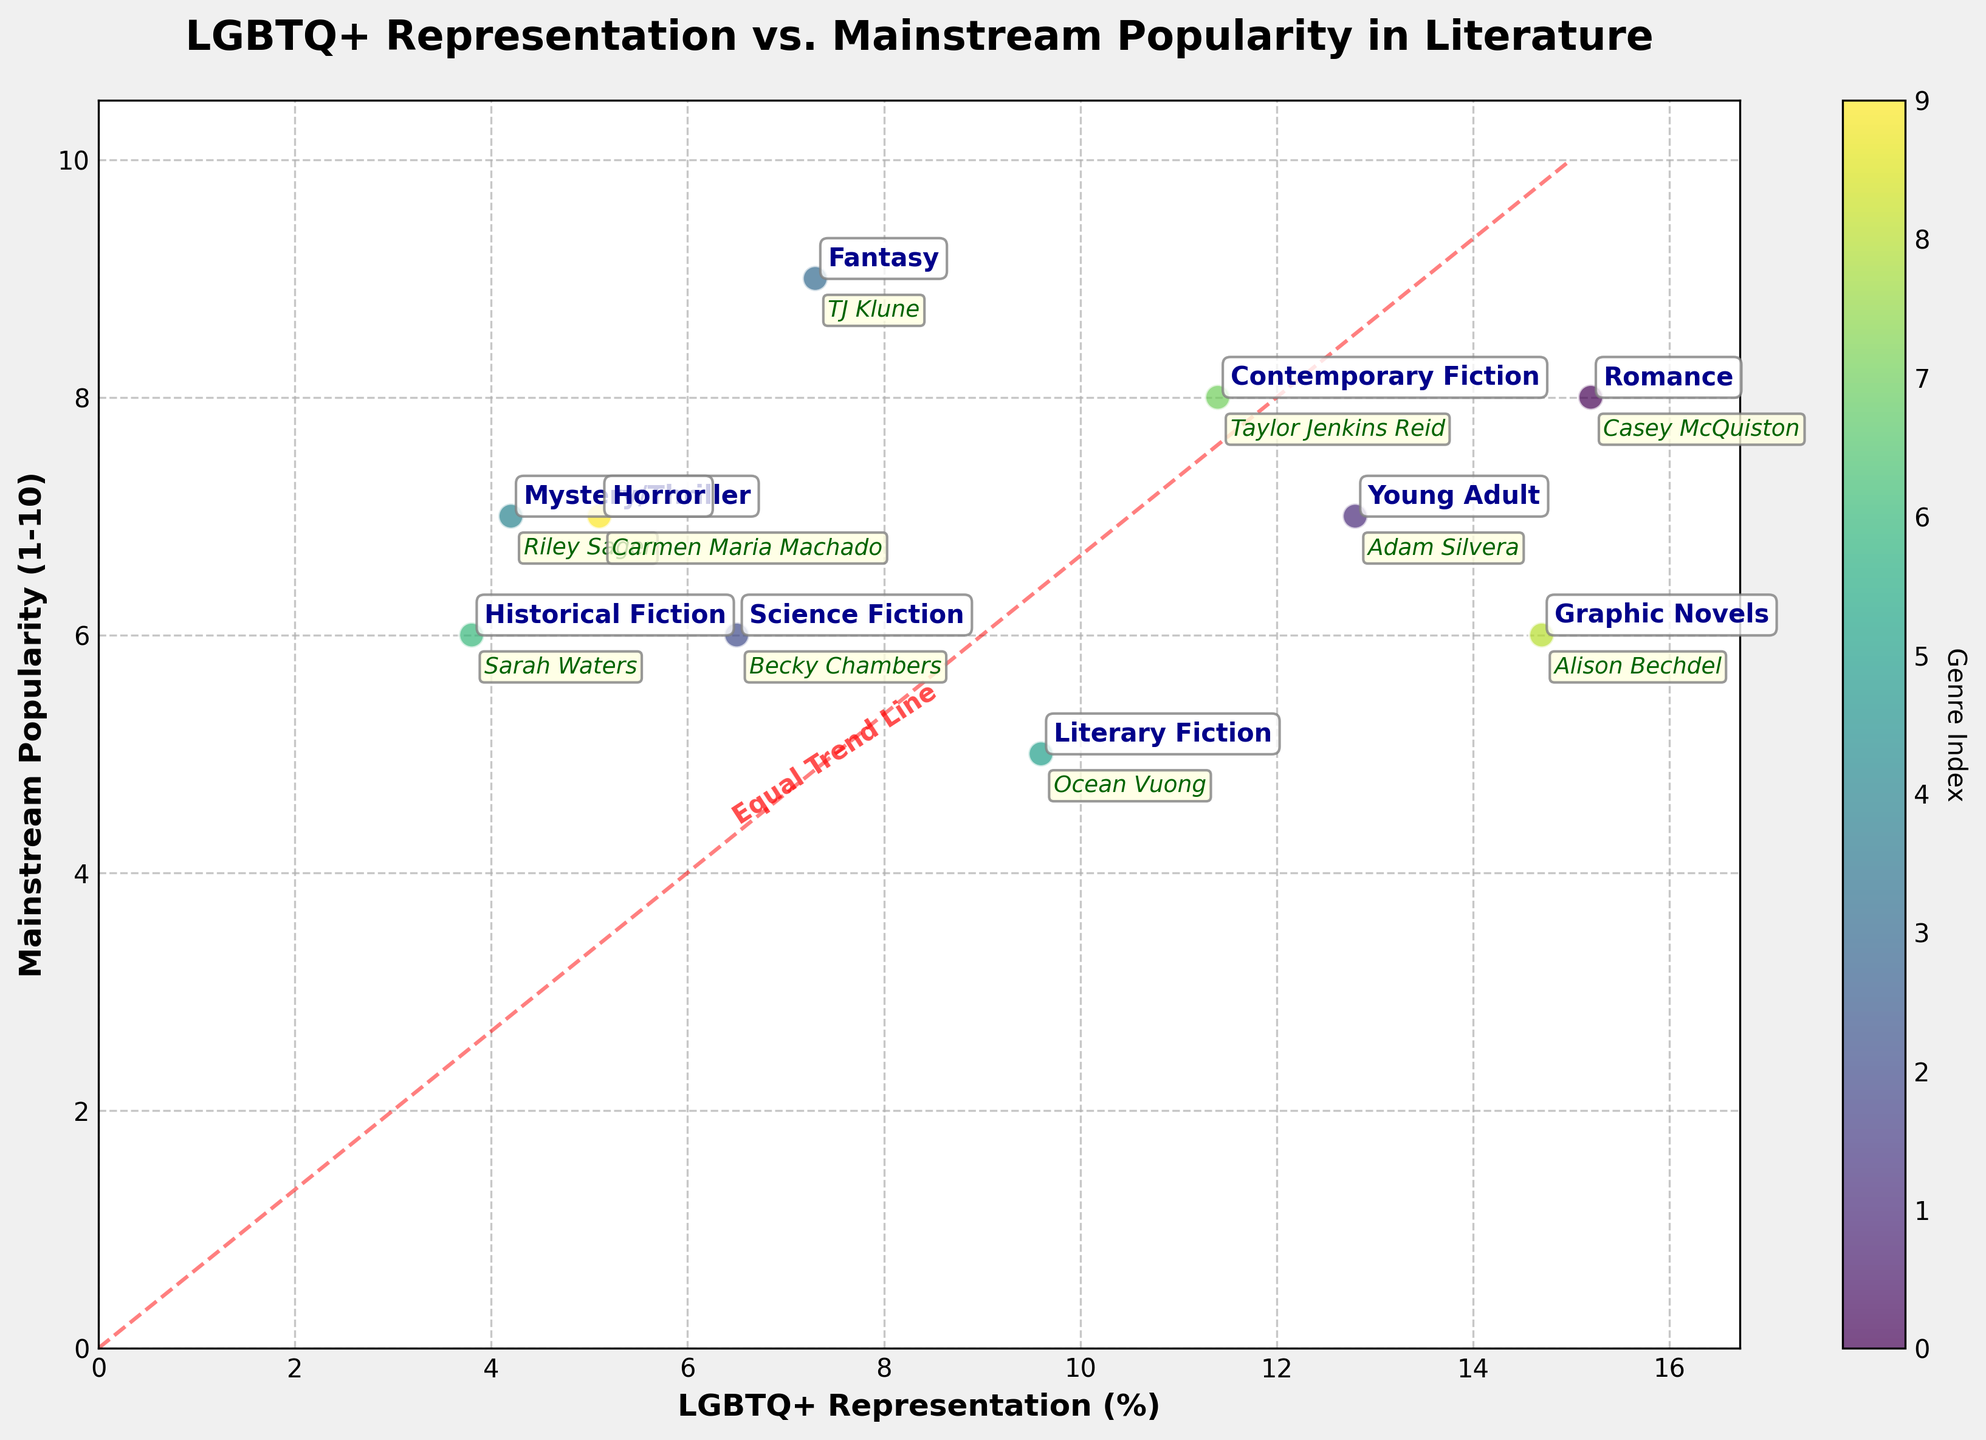What is the genre with the highest LGBTQ+ representation? To identify the genre with the highest LGBTQ+ representation, look at the x-axis (LGBTQ+ Representation) and find the highest data point. This corresponds to the genre "Romance" with 15.2% representation.
Answer: Romance Which genres have LGBTQ+ representation higher than 10%? Locate the data points on the x-axis that are greater than 10%. The corresponding genres are "Romance" (15.2%), "Graphic Novels" (14.7%), "Contemporary Fiction" (11.4%), and "Young Adult" (12.8%).
Answer: Romance, Graphic Novels, Contemporary Fiction, Young Adult What is the relationship between LGBTQ+ representation and popularity for Romance? For the Romance genre, identify its data point on the scatter plot. It has an LGBTQ+ representation of 15.2% and a mainstream popularity score of 8.
Answer: 15.2% representation and 8 popularity How many genres have a mainstream popularity score of 7? Count the data points on the y-axis that align with the value 7. These are "Young Adult", "Mystery/Thriller", and "Horror", making a total of three genres.
Answer: 3 genres Which genre has the lowest LGBTQ+ representation and what is its mainstream popularity? Find the data point on the far left of the x-axis. This corresponds to the genre "Historical Fiction" with 3.8% representation and a popularity score of 6.
Answer: Historical Fiction with 6 popularity Is there any genre that has both high LGBTQ+ representation and high mainstream popularity? Look for data points that are high on both x (LGBTQ+ Representation) and y (Mainstream Popularity) axes. Romance (15.2% and 8) and Contemporary Fiction (11.4% and 8) fit this criterion.
Answer: Romance and Contemporary Fiction Compare the LGBTQ+ representation and popularity between Fantasy and Science Fiction. Fantasy has an LGBTQ+ representation of 7.3% and a popularity score of 9. Science Fiction has 6.5% representation and a popularity score of 6.
Answer: Fantasy: 7.3% and 9, Science Fiction: 6.5% and 6 What is the average LGBTQ+ representation of all the genres shown? Add up all the LGBTQ+ representations and divide by the number of genres. (15.2 + 12.8 + 6.5 + 7.3 + 4.2 + 9.6 + 3.8 + 11.4 + 14.7 + 5.1) / 10 = 9.06%
Answer: 9.06% Identify the genre with the notable author Ocean Vuong. What are its LGBTQ+ representation and popularity? Find the data point labeled with Ocean Vuong. The genre is "Literary Fiction", which has 9.6% LGBTQ+ representation and a popularity score of 5.
Answer: Literary Fiction, 9.6% and 5 